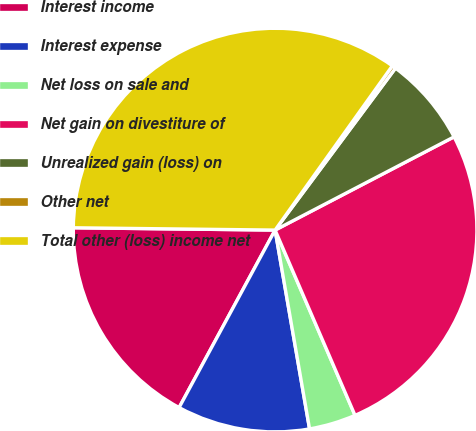<chart> <loc_0><loc_0><loc_500><loc_500><pie_chart><fcel>Interest income<fcel>Interest expense<fcel>Net loss on sale and<fcel>Net gain on divestiture of<fcel>Unrealized gain (loss) on<fcel>Other net<fcel>Total other (loss) income net<nl><fcel>17.29%<fcel>10.62%<fcel>3.75%<fcel>26.16%<fcel>7.18%<fcel>0.31%<fcel>34.68%<nl></chart> 